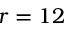<formula> <loc_0><loc_0><loc_500><loc_500>r = 1 2</formula> 